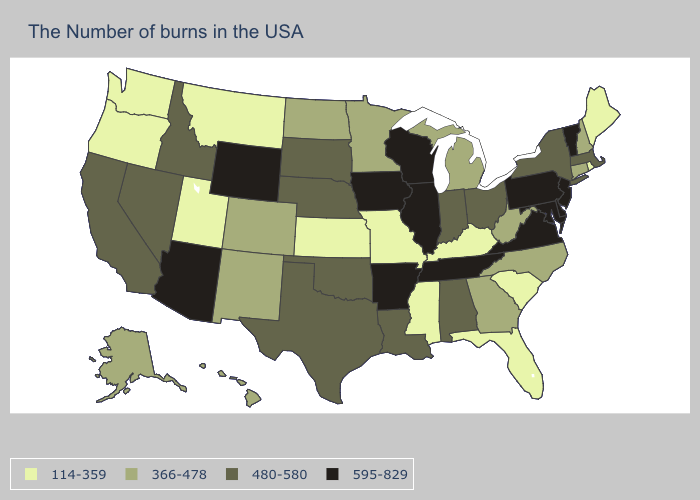What is the lowest value in states that border Massachusetts?
Write a very short answer. 114-359. Does Utah have the highest value in the West?
Give a very brief answer. No. Which states have the lowest value in the USA?
Answer briefly. Maine, Rhode Island, South Carolina, Florida, Kentucky, Mississippi, Missouri, Kansas, Utah, Montana, Washington, Oregon. What is the value of Michigan?
Write a very short answer. 366-478. Name the states that have a value in the range 366-478?
Short answer required. New Hampshire, Connecticut, North Carolina, West Virginia, Georgia, Michigan, Minnesota, North Dakota, Colorado, New Mexico, Alaska, Hawaii. What is the value of Connecticut?
Keep it brief. 366-478. Does Georgia have the same value as New Hampshire?
Be succinct. Yes. Among the states that border New York , which have the lowest value?
Keep it brief. Connecticut. Does Maine have the lowest value in the Northeast?
Be succinct. Yes. Does Rhode Island have the same value as Wisconsin?
Write a very short answer. No. Does Wisconsin have the highest value in the USA?
Quick response, please. Yes. Does Alabama have the same value as New York?
Keep it brief. Yes. Name the states that have a value in the range 114-359?
Answer briefly. Maine, Rhode Island, South Carolina, Florida, Kentucky, Mississippi, Missouri, Kansas, Utah, Montana, Washington, Oregon. What is the lowest value in the MidWest?
Answer briefly. 114-359. What is the highest value in the MidWest ?
Short answer required. 595-829. 